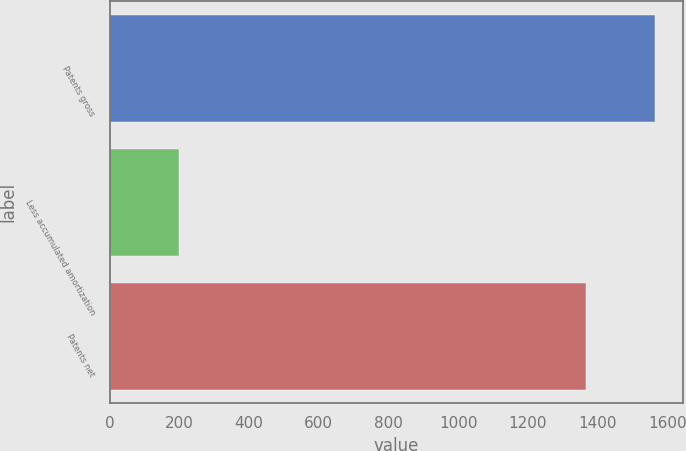<chart> <loc_0><loc_0><loc_500><loc_500><bar_chart><fcel>Patents gross<fcel>Less accumulated amortization<fcel>Patents net<nl><fcel>1566<fcel>200<fcel>1366<nl></chart> 